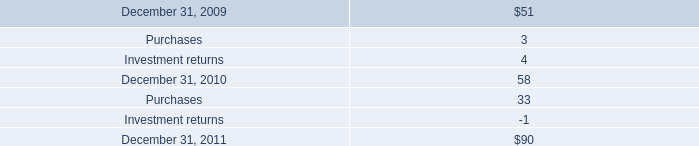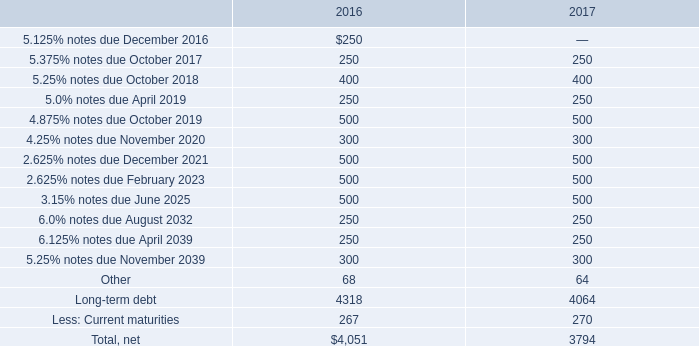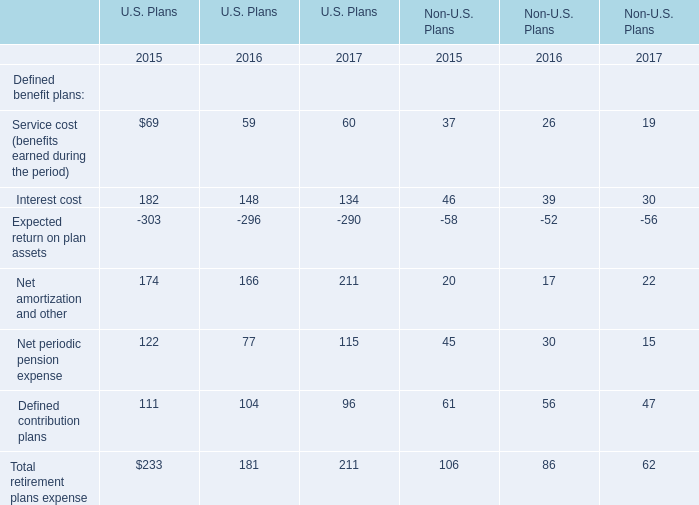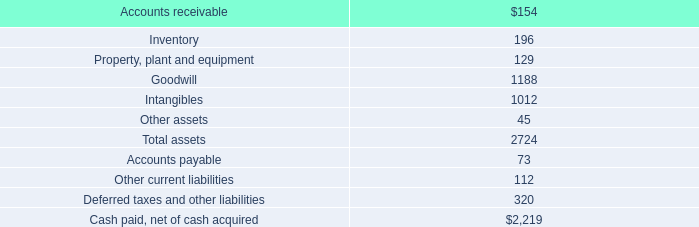What was the average of the 6.125% notes due April 2039 and 5.25% notes due November 2039 in the years where Long-term debt is positive? 
Computations: ((250 + 300) / 2)
Answer: 275.0. 